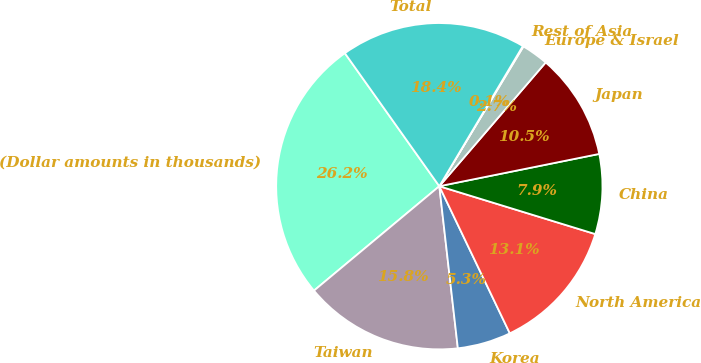Convert chart. <chart><loc_0><loc_0><loc_500><loc_500><pie_chart><fcel>(Dollar amounts in thousands)<fcel>Taiwan<fcel>Korea<fcel>North America<fcel>China<fcel>Japan<fcel>Europe & Israel<fcel>Rest of Asia<fcel>Total<nl><fcel>26.23%<fcel>15.76%<fcel>5.3%<fcel>13.15%<fcel>7.91%<fcel>10.53%<fcel>2.68%<fcel>0.07%<fcel>18.38%<nl></chart> 